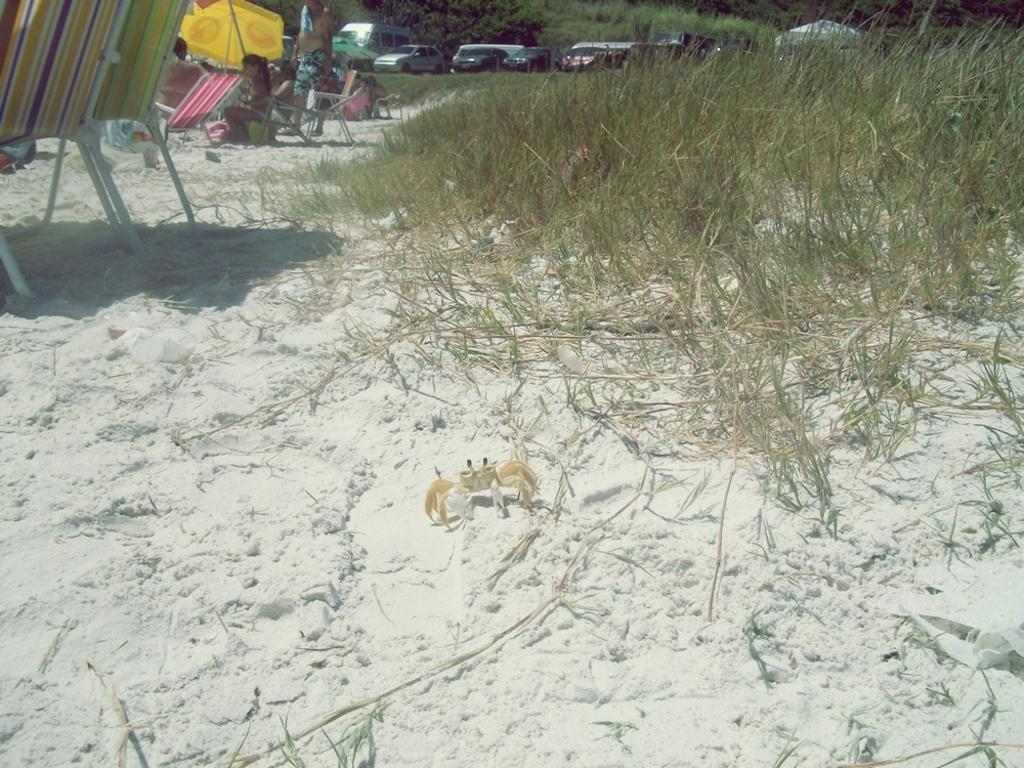What type of vegetation is present in the image? There is grass in the image. What can be seen on the white surface? There are chairs on a white surface. Who or what is present in the image? There are people in the image. What is used for shade in the image? There is an umbrella in the image. What can be seen in the background of the image? There are trees and vehicles in the background of the image. What is the reaction of the engine to the direction of the wind in the image? There is no engine present in the image, and therefore no reaction to the direction of the wind can be observed. 